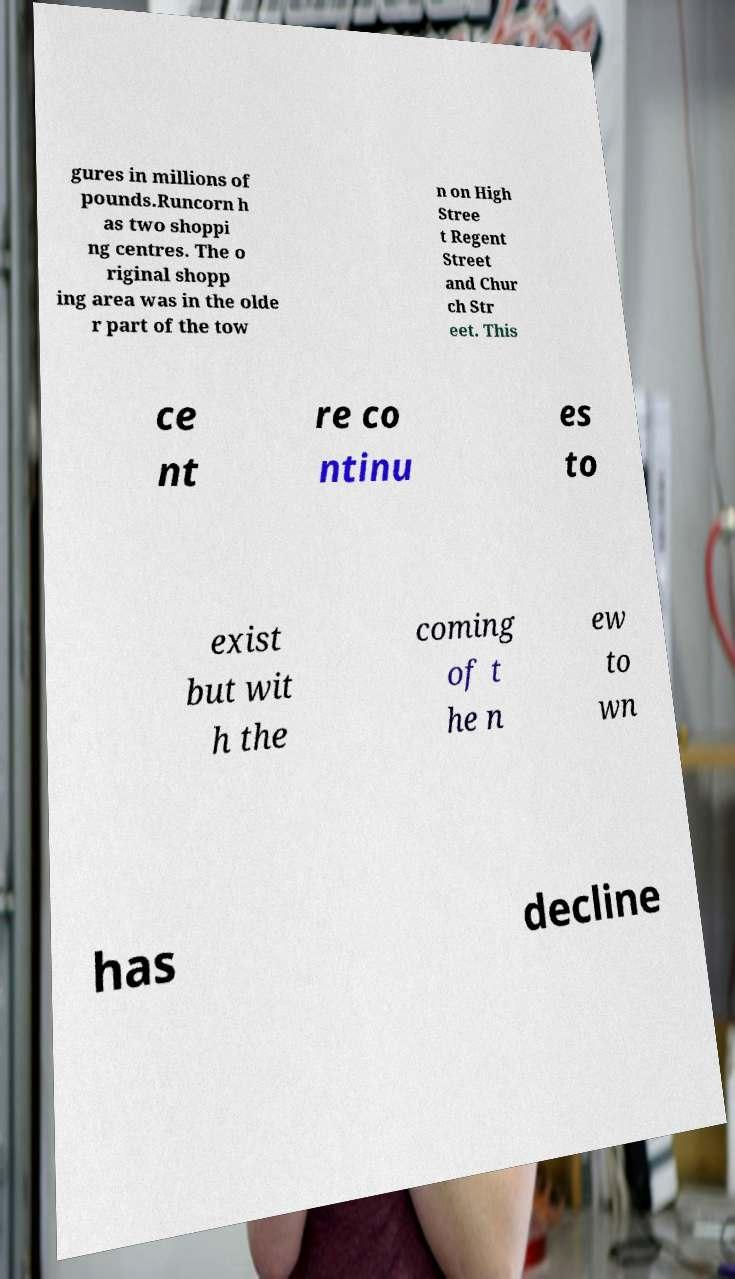Please read and relay the text visible in this image. What does it say? gures in millions of pounds.Runcorn h as two shoppi ng centres. The o riginal shopp ing area was in the olde r part of the tow n on High Stree t Regent Street and Chur ch Str eet. This ce nt re co ntinu es to exist but wit h the coming of t he n ew to wn has decline 